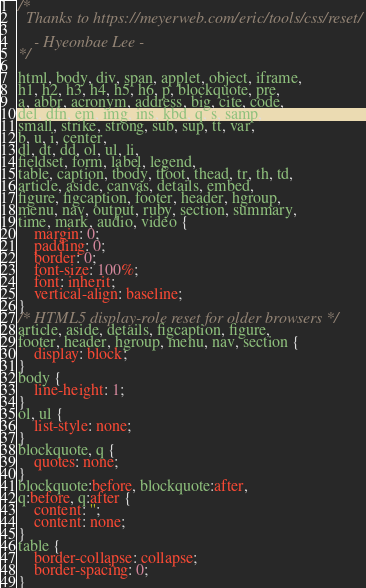Convert code to text. <code><loc_0><loc_0><loc_500><loc_500><_CSS_>/* 
  Thanks to https://meyerweb.com/eric/tools/css/reset/ 

	- Hyeonbae Lee -
*/

html, body, div, span, applet, object, iframe,
h1, h2, h3, h4, h5, h6, p, blockquote, pre,
a, abbr, acronym, address, big, cite, code,
del, dfn, em, img, ins, kbd, q, s, samp,
small, strike, strong, sub, sup, tt, var,
b, u, i, center,
dl, dt, dd, ol, ul, li,
fieldset, form, label, legend,
table, caption, tbody, tfoot, thead, tr, th, td,
article, aside, canvas, details, embed, 
figure, figcaption, footer, header, hgroup, 
menu, nav, output, ruby, section, summary,
time, mark, audio, video {
	margin: 0;
	padding: 0;
	border: 0;
	font-size: 100%;
	font: inherit;
	vertical-align: baseline;
}
/* HTML5 display-role reset for older browsers */
article, aside, details, figcaption, figure, 
footer, header, hgroup, menu, nav, section {
	display: block;
}
body {
	line-height: 1;
}
ol, ul {
	list-style: none;
}
blockquote, q {
	quotes: none;
}
blockquote:before, blockquote:after,
q:before, q:after {
	content: '';
	content: none;
}
table {
	border-collapse: collapse;
	border-spacing: 0;
}</code> 